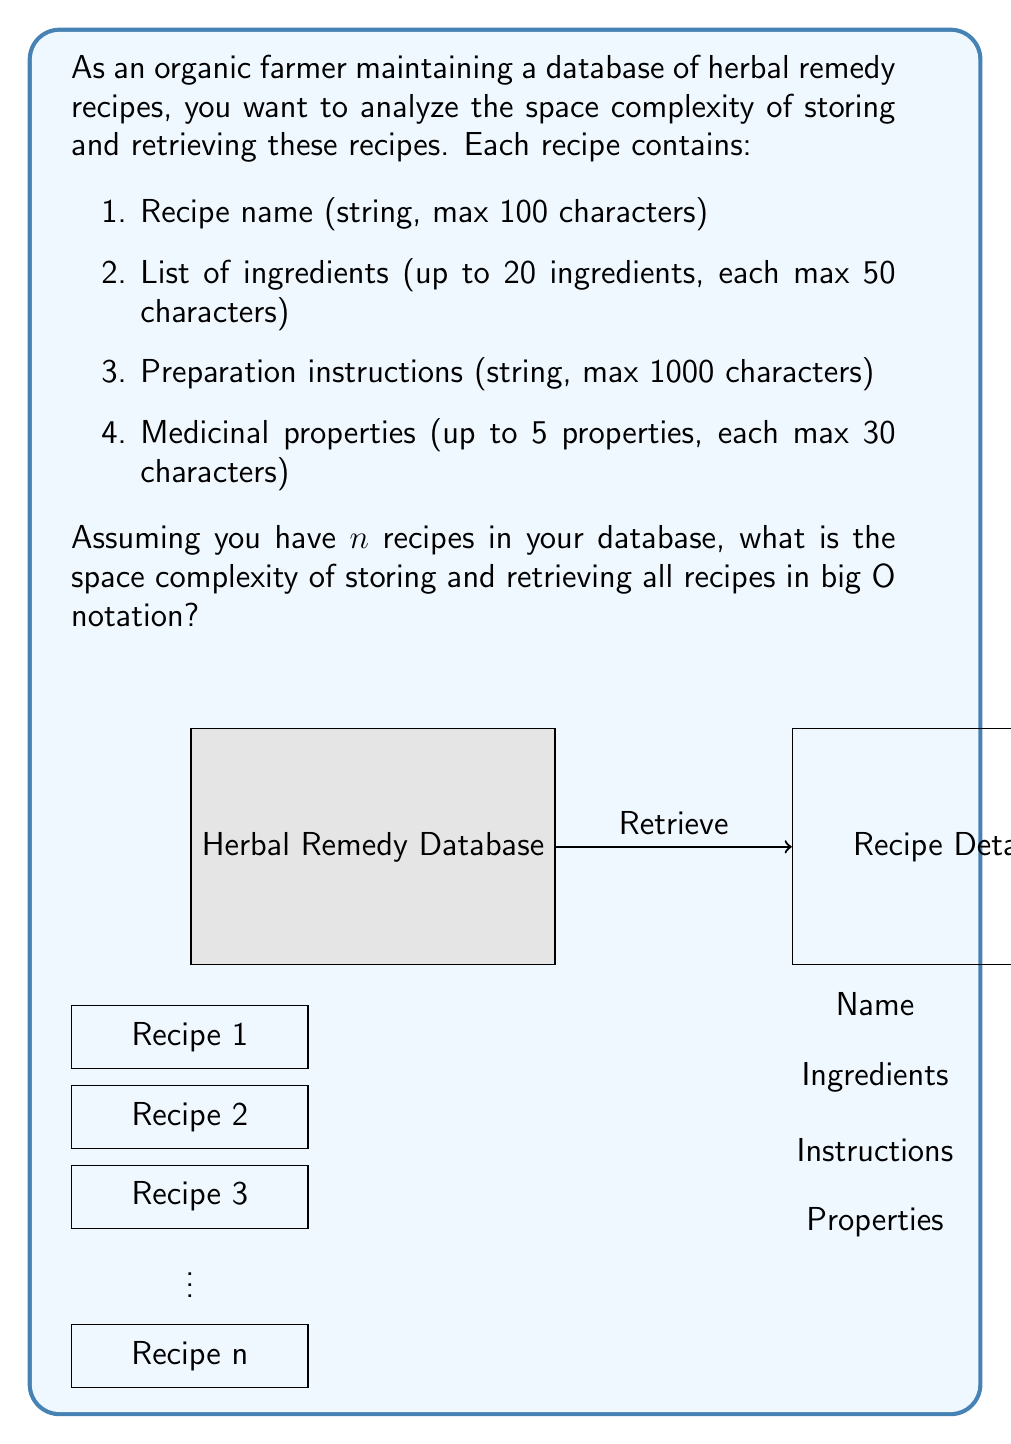What is the answer to this math problem? To determine the space complexity, we need to calculate the maximum space required for each recipe and then multiply it by the number of recipes. Let's break it down step-by-step:

1. Recipe name: 
   - Max 100 characters
   - Space: $O(100)$ = $O(1)$ (constant)

2. List of ingredients:
   - Up to 20 ingredients, each max 50 characters
   - Space: $20 \times 50 = 1000$ characters
   - $O(1000)$ = $O(1)$ (constant)

3. Preparation instructions:
   - Max 1000 characters
   - Space: $O(1000)$ = $O(1)$ (constant)

4. Medicinal properties:
   - Up to 5 properties, each max 30 characters
   - Space: $5 \times 30 = 150$ characters
   - $O(150)$ = $O(1)$ (constant)

Total space for one recipe:
$$O(1) + O(1) + O(1) + O(1) = O(1)$$

For $n$ recipes, the total space complexity would be:
$$O(n \times 1) = O(n)$$

The space complexity for retrieving recipes is also $O(n)$ in the worst case, as we might need to scan through all recipes to find a specific one.

Therefore, the overall space complexity for storing and retrieving $n$ recipes is $O(n)$.
Answer: $O(n)$ 